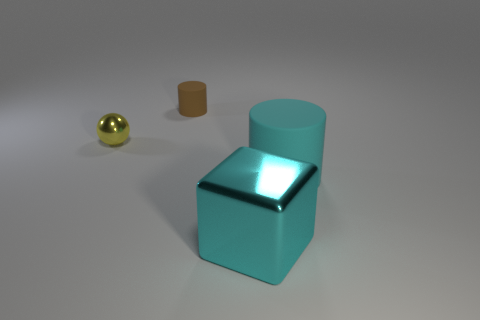What number of other things are there of the same color as the large rubber thing?
Provide a short and direct response. 1. There is a matte thing that is to the right of the rubber cylinder that is to the left of the cyan object that is right of the large shiny object; what is its size?
Offer a terse response. Large. There is a big cyan metal thing; are there any large cyan metal things in front of it?
Give a very brief answer. No. Is the size of the cyan metal cube the same as the cyan thing that is right of the big cyan shiny cube?
Give a very brief answer. Yes. How many other objects are the same material as the cyan cylinder?
Give a very brief answer. 1. There is a thing that is on the right side of the small metallic object and left of the big cyan cube; what shape is it?
Ensure brevity in your answer.  Cylinder. There is a matte object behind the tiny yellow metal sphere; is it the same size as the rubber cylinder in front of the brown cylinder?
Give a very brief answer. No. There is a tiny yellow object that is made of the same material as the block; what is its shape?
Your response must be concise. Sphere. Is there anything else that has the same shape as the yellow metal object?
Make the answer very short. No. There is a cylinder that is on the right side of the cylinder behind the tiny object in front of the small cylinder; what is its color?
Your answer should be compact. Cyan. 